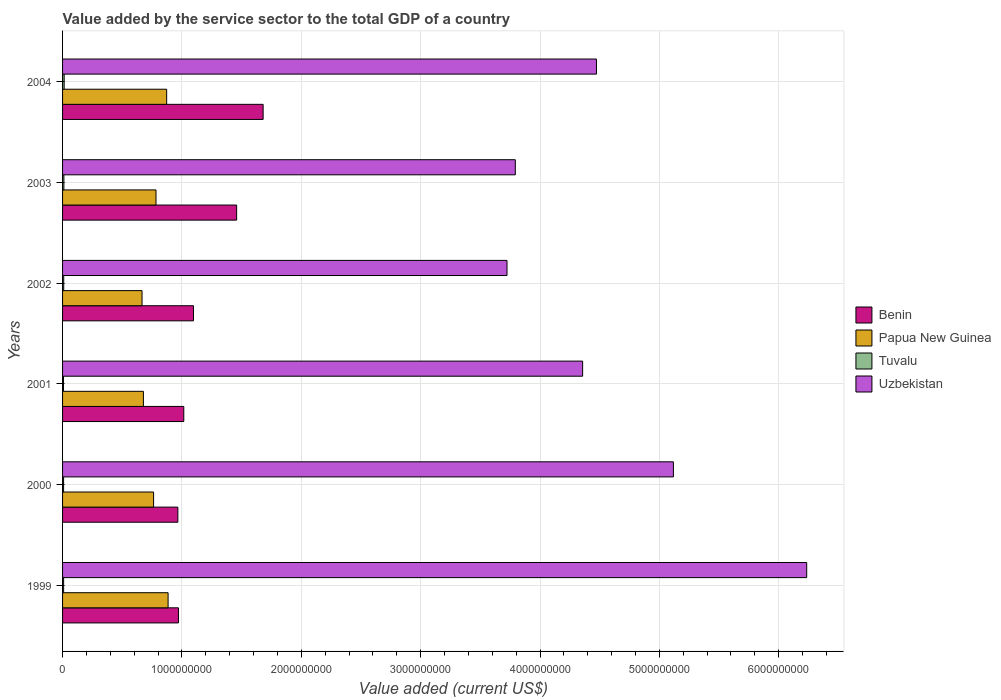How many different coloured bars are there?
Offer a terse response. 4. How many groups of bars are there?
Provide a succinct answer. 6. Are the number of bars per tick equal to the number of legend labels?
Keep it short and to the point. Yes. Are the number of bars on each tick of the Y-axis equal?
Your response must be concise. Yes. What is the value added by the service sector to the total GDP in Tuvalu in 2000?
Your answer should be very brief. 8.64e+06. Across all years, what is the maximum value added by the service sector to the total GDP in Papua New Guinea?
Offer a very short reply. 8.84e+08. Across all years, what is the minimum value added by the service sector to the total GDP in Uzbekistan?
Give a very brief answer. 3.72e+09. What is the total value added by the service sector to the total GDP in Uzbekistan in the graph?
Keep it short and to the point. 2.77e+1. What is the difference between the value added by the service sector to the total GDP in Papua New Guinea in 1999 and that in 2001?
Make the answer very short. 2.07e+08. What is the difference between the value added by the service sector to the total GDP in Tuvalu in 2004 and the value added by the service sector to the total GDP in Benin in 2000?
Make the answer very short. -9.53e+08. What is the average value added by the service sector to the total GDP in Benin per year?
Give a very brief answer. 1.20e+09. In the year 2004, what is the difference between the value added by the service sector to the total GDP in Benin and value added by the service sector to the total GDP in Tuvalu?
Ensure brevity in your answer.  1.67e+09. In how many years, is the value added by the service sector to the total GDP in Uzbekistan greater than 3800000000 US$?
Your answer should be very brief. 4. What is the ratio of the value added by the service sector to the total GDP in Tuvalu in 2000 to that in 2001?
Give a very brief answer. 1.09. What is the difference between the highest and the second highest value added by the service sector to the total GDP in Tuvalu?
Make the answer very short. 2.23e+06. What is the difference between the highest and the lowest value added by the service sector to the total GDP in Uzbekistan?
Your response must be concise. 2.51e+09. Is it the case that in every year, the sum of the value added by the service sector to the total GDP in Uzbekistan and value added by the service sector to the total GDP in Tuvalu is greater than the sum of value added by the service sector to the total GDP in Papua New Guinea and value added by the service sector to the total GDP in Benin?
Your response must be concise. Yes. What does the 2nd bar from the top in 2004 represents?
Give a very brief answer. Tuvalu. What does the 3rd bar from the bottom in 2000 represents?
Provide a succinct answer. Tuvalu. Are all the bars in the graph horizontal?
Offer a terse response. Yes. How many years are there in the graph?
Give a very brief answer. 6. What is the difference between two consecutive major ticks on the X-axis?
Your response must be concise. 1.00e+09. Are the values on the major ticks of X-axis written in scientific E-notation?
Your answer should be very brief. No. How are the legend labels stacked?
Your answer should be compact. Vertical. What is the title of the graph?
Your answer should be compact. Value added by the service sector to the total GDP of a country. What is the label or title of the X-axis?
Offer a terse response. Value added (current US$). What is the label or title of the Y-axis?
Provide a succinct answer. Years. What is the Value added (current US$) of Benin in 1999?
Your answer should be compact. 9.71e+08. What is the Value added (current US$) of Papua New Guinea in 1999?
Provide a succinct answer. 8.84e+08. What is the Value added (current US$) of Tuvalu in 1999?
Ensure brevity in your answer.  8.89e+06. What is the Value added (current US$) of Uzbekistan in 1999?
Keep it short and to the point. 6.23e+09. What is the Value added (current US$) of Benin in 2000?
Provide a succinct answer. 9.66e+08. What is the Value added (current US$) of Papua New Guinea in 2000?
Ensure brevity in your answer.  7.63e+08. What is the Value added (current US$) in Tuvalu in 2000?
Offer a very short reply. 8.64e+06. What is the Value added (current US$) in Uzbekistan in 2000?
Your response must be concise. 5.12e+09. What is the Value added (current US$) in Benin in 2001?
Give a very brief answer. 1.02e+09. What is the Value added (current US$) of Papua New Guinea in 2001?
Ensure brevity in your answer.  6.77e+08. What is the Value added (current US$) of Tuvalu in 2001?
Your answer should be very brief. 7.93e+06. What is the Value added (current US$) in Uzbekistan in 2001?
Your answer should be very brief. 4.36e+09. What is the Value added (current US$) in Benin in 2002?
Your answer should be compact. 1.10e+09. What is the Value added (current US$) of Papua New Guinea in 2002?
Your response must be concise. 6.66e+08. What is the Value added (current US$) in Tuvalu in 2002?
Your answer should be compact. 9.67e+06. What is the Value added (current US$) in Uzbekistan in 2002?
Provide a succinct answer. 3.72e+09. What is the Value added (current US$) in Benin in 2003?
Offer a very short reply. 1.46e+09. What is the Value added (current US$) in Papua New Guinea in 2003?
Give a very brief answer. 7.83e+08. What is the Value added (current US$) of Tuvalu in 2003?
Provide a short and direct response. 1.11e+07. What is the Value added (current US$) of Uzbekistan in 2003?
Provide a short and direct response. 3.79e+09. What is the Value added (current US$) in Benin in 2004?
Give a very brief answer. 1.68e+09. What is the Value added (current US$) in Papua New Guinea in 2004?
Your response must be concise. 8.72e+08. What is the Value added (current US$) in Tuvalu in 2004?
Give a very brief answer. 1.33e+07. What is the Value added (current US$) in Uzbekistan in 2004?
Offer a terse response. 4.47e+09. Across all years, what is the maximum Value added (current US$) of Benin?
Give a very brief answer. 1.68e+09. Across all years, what is the maximum Value added (current US$) of Papua New Guinea?
Ensure brevity in your answer.  8.84e+08. Across all years, what is the maximum Value added (current US$) of Tuvalu?
Offer a terse response. 1.33e+07. Across all years, what is the maximum Value added (current US$) of Uzbekistan?
Provide a succinct answer. 6.23e+09. Across all years, what is the minimum Value added (current US$) in Benin?
Ensure brevity in your answer.  9.66e+08. Across all years, what is the minimum Value added (current US$) in Papua New Guinea?
Offer a very short reply. 6.66e+08. Across all years, what is the minimum Value added (current US$) of Tuvalu?
Make the answer very short. 7.93e+06. Across all years, what is the minimum Value added (current US$) of Uzbekistan?
Your answer should be compact. 3.72e+09. What is the total Value added (current US$) in Benin in the graph?
Offer a very short reply. 7.19e+09. What is the total Value added (current US$) in Papua New Guinea in the graph?
Provide a short and direct response. 4.64e+09. What is the total Value added (current US$) of Tuvalu in the graph?
Your answer should be compact. 5.96e+07. What is the total Value added (current US$) in Uzbekistan in the graph?
Offer a very short reply. 2.77e+1. What is the difference between the Value added (current US$) in Benin in 1999 and that in 2000?
Ensure brevity in your answer.  5.03e+06. What is the difference between the Value added (current US$) of Papua New Guinea in 1999 and that in 2000?
Ensure brevity in your answer.  1.21e+08. What is the difference between the Value added (current US$) in Tuvalu in 1999 and that in 2000?
Give a very brief answer. 2.47e+05. What is the difference between the Value added (current US$) in Uzbekistan in 1999 and that in 2000?
Give a very brief answer. 1.12e+09. What is the difference between the Value added (current US$) in Benin in 1999 and that in 2001?
Provide a short and direct response. -4.46e+07. What is the difference between the Value added (current US$) in Papua New Guinea in 1999 and that in 2001?
Your answer should be compact. 2.07e+08. What is the difference between the Value added (current US$) in Tuvalu in 1999 and that in 2001?
Offer a very short reply. 9.64e+05. What is the difference between the Value added (current US$) in Uzbekistan in 1999 and that in 2001?
Your answer should be very brief. 1.88e+09. What is the difference between the Value added (current US$) of Benin in 1999 and that in 2002?
Give a very brief answer. -1.26e+08. What is the difference between the Value added (current US$) in Papua New Guinea in 1999 and that in 2002?
Keep it short and to the point. 2.18e+08. What is the difference between the Value added (current US$) in Tuvalu in 1999 and that in 2002?
Your answer should be very brief. -7.76e+05. What is the difference between the Value added (current US$) of Uzbekistan in 1999 and that in 2002?
Offer a very short reply. 2.51e+09. What is the difference between the Value added (current US$) of Benin in 1999 and that in 2003?
Provide a short and direct response. -4.87e+08. What is the difference between the Value added (current US$) of Papua New Guinea in 1999 and that in 2003?
Provide a succinct answer. 1.01e+08. What is the difference between the Value added (current US$) in Tuvalu in 1999 and that in 2003?
Give a very brief answer. -2.22e+06. What is the difference between the Value added (current US$) in Uzbekistan in 1999 and that in 2003?
Provide a short and direct response. 2.44e+09. What is the difference between the Value added (current US$) in Benin in 1999 and that in 2004?
Provide a succinct answer. -7.09e+08. What is the difference between the Value added (current US$) of Papua New Guinea in 1999 and that in 2004?
Ensure brevity in your answer.  1.20e+07. What is the difference between the Value added (current US$) in Tuvalu in 1999 and that in 2004?
Your response must be concise. -4.46e+06. What is the difference between the Value added (current US$) of Uzbekistan in 1999 and that in 2004?
Provide a succinct answer. 1.76e+09. What is the difference between the Value added (current US$) of Benin in 2000 and that in 2001?
Your answer should be compact. -4.96e+07. What is the difference between the Value added (current US$) in Papua New Guinea in 2000 and that in 2001?
Offer a terse response. 8.54e+07. What is the difference between the Value added (current US$) in Tuvalu in 2000 and that in 2001?
Offer a terse response. 7.17e+05. What is the difference between the Value added (current US$) of Uzbekistan in 2000 and that in 2001?
Ensure brevity in your answer.  7.60e+08. What is the difference between the Value added (current US$) in Benin in 2000 and that in 2002?
Keep it short and to the point. -1.31e+08. What is the difference between the Value added (current US$) in Papua New Guinea in 2000 and that in 2002?
Offer a very short reply. 9.69e+07. What is the difference between the Value added (current US$) of Tuvalu in 2000 and that in 2002?
Keep it short and to the point. -1.02e+06. What is the difference between the Value added (current US$) of Uzbekistan in 2000 and that in 2002?
Offer a terse response. 1.39e+09. What is the difference between the Value added (current US$) in Benin in 2000 and that in 2003?
Provide a succinct answer. -4.92e+08. What is the difference between the Value added (current US$) of Papua New Guinea in 2000 and that in 2003?
Give a very brief answer. -2.01e+07. What is the difference between the Value added (current US$) in Tuvalu in 2000 and that in 2003?
Offer a terse response. -2.47e+06. What is the difference between the Value added (current US$) in Uzbekistan in 2000 and that in 2003?
Ensure brevity in your answer.  1.32e+09. What is the difference between the Value added (current US$) of Benin in 2000 and that in 2004?
Your answer should be very brief. -7.14e+08. What is the difference between the Value added (current US$) of Papua New Guinea in 2000 and that in 2004?
Your response must be concise. -1.09e+08. What is the difference between the Value added (current US$) of Tuvalu in 2000 and that in 2004?
Make the answer very short. -4.70e+06. What is the difference between the Value added (current US$) of Uzbekistan in 2000 and that in 2004?
Offer a very short reply. 6.45e+08. What is the difference between the Value added (current US$) in Benin in 2001 and that in 2002?
Make the answer very short. -8.14e+07. What is the difference between the Value added (current US$) of Papua New Guinea in 2001 and that in 2002?
Keep it short and to the point. 1.15e+07. What is the difference between the Value added (current US$) of Tuvalu in 2001 and that in 2002?
Offer a very short reply. -1.74e+06. What is the difference between the Value added (current US$) of Uzbekistan in 2001 and that in 2002?
Your answer should be compact. 6.34e+08. What is the difference between the Value added (current US$) in Benin in 2001 and that in 2003?
Provide a short and direct response. -4.43e+08. What is the difference between the Value added (current US$) of Papua New Guinea in 2001 and that in 2003?
Your answer should be compact. -1.06e+08. What is the difference between the Value added (current US$) of Tuvalu in 2001 and that in 2003?
Provide a short and direct response. -3.19e+06. What is the difference between the Value added (current US$) in Uzbekistan in 2001 and that in 2003?
Provide a short and direct response. 5.64e+08. What is the difference between the Value added (current US$) of Benin in 2001 and that in 2004?
Make the answer very short. -6.65e+08. What is the difference between the Value added (current US$) in Papua New Guinea in 2001 and that in 2004?
Ensure brevity in your answer.  -1.95e+08. What is the difference between the Value added (current US$) of Tuvalu in 2001 and that in 2004?
Offer a very short reply. -5.42e+06. What is the difference between the Value added (current US$) in Uzbekistan in 2001 and that in 2004?
Provide a short and direct response. -1.16e+08. What is the difference between the Value added (current US$) in Benin in 2002 and that in 2003?
Provide a short and direct response. -3.61e+08. What is the difference between the Value added (current US$) in Papua New Guinea in 2002 and that in 2003?
Offer a terse response. -1.17e+08. What is the difference between the Value added (current US$) in Tuvalu in 2002 and that in 2003?
Your answer should be very brief. -1.45e+06. What is the difference between the Value added (current US$) of Uzbekistan in 2002 and that in 2003?
Provide a short and direct response. -6.96e+07. What is the difference between the Value added (current US$) of Benin in 2002 and that in 2004?
Your response must be concise. -5.83e+08. What is the difference between the Value added (current US$) of Papua New Guinea in 2002 and that in 2004?
Your answer should be compact. -2.06e+08. What is the difference between the Value added (current US$) of Tuvalu in 2002 and that in 2004?
Offer a very short reply. -3.68e+06. What is the difference between the Value added (current US$) in Uzbekistan in 2002 and that in 2004?
Offer a terse response. -7.49e+08. What is the difference between the Value added (current US$) in Benin in 2003 and that in 2004?
Your answer should be very brief. -2.22e+08. What is the difference between the Value added (current US$) in Papua New Guinea in 2003 and that in 2004?
Ensure brevity in your answer.  -8.93e+07. What is the difference between the Value added (current US$) in Tuvalu in 2003 and that in 2004?
Provide a short and direct response. -2.23e+06. What is the difference between the Value added (current US$) of Uzbekistan in 2003 and that in 2004?
Provide a short and direct response. -6.80e+08. What is the difference between the Value added (current US$) in Benin in 1999 and the Value added (current US$) in Papua New Guinea in 2000?
Offer a terse response. 2.08e+08. What is the difference between the Value added (current US$) in Benin in 1999 and the Value added (current US$) in Tuvalu in 2000?
Provide a succinct answer. 9.62e+08. What is the difference between the Value added (current US$) of Benin in 1999 and the Value added (current US$) of Uzbekistan in 2000?
Offer a very short reply. -4.15e+09. What is the difference between the Value added (current US$) of Papua New Guinea in 1999 and the Value added (current US$) of Tuvalu in 2000?
Your answer should be very brief. 8.75e+08. What is the difference between the Value added (current US$) of Papua New Guinea in 1999 and the Value added (current US$) of Uzbekistan in 2000?
Your response must be concise. -4.23e+09. What is the difference between the Value added (current US$) in Tuvalu in 1999 and the Value added (current US$) in Uzbekistan in 2000?
Your answer should be compact. -5.11e+09. What is the difference between the Value added (current US$) of Benin in 1999 and the Value added (current US$) of Papua New Guinea in 2001?
Ensure brevity in your answer.  2.94e+08. What is the difference between the Value added (current US$) in Benin in 1999 and the Value added (current US$) in Tuvalu in 2001?
Provide a succinct answer. 9.63e+08. What is the difference between the Value added (current US$) in Benin in 1999 and the Value added (current US$) in Uzbekistan in 2001?
Provide a short and direct response. -3.39e+09. What is the difference between the Value added (current US$) in Papua New Guinea in 1999 and the Value added (current US$) in Tuvalu in 2001?
Your answer should be very brief. 8.76e+08. What is the difference between the Value added (current US$) of Papua New Guinea in 1999 and the Value added (current US$) of Uzbekistan in 2001?
Your answer should be very brief. -3.47e+09. What is the difference between the Value added (current US$) of Tuvalu in 1999 and the Value added (current US$) of Uzbekistan in 2001?
Offer a very short reply. -4.35e+09. What is the difference between the Value added (current US$) of Benin in 1999 and the Value added (current US$) of Papua New Guinea in 2002?
Make the answer very short. 3.05e+08. What is the difference between the Value added (current US$) of Benin in 1999 and the Value added (current US$) of Tuvalu in 2002?
Provide a succinct answer. 9.61e+08. What is the difference between the Value added (current US$) in Benin in 1999 and the Value added (current US$) in Uzbekistan in 2002?
Provide a succinct answer. -2.75e+09. What is the difference between the Value added (current US$) in Papua New Guinea in 1999 and the Value added (current US$) in Tuvalu in 2002?
Your answer should be compact. 8.74e+08. What is the difference between the Value added (current US$) in Papua New Guinea in 1999 and the Value added (current US$) in Uzbekistan in 2002?
Offer a terse response. -2.84e+09. What is the difference between the Value added (current US$) in Tuvalu in 1999 and the Value added (current US$) in Uzbekistan in 2002?
Keep it short and to the point. -3.71e+09. What is the difference between the Value added (current US$) in Benin in 1999 and the Value added (current US$) in Papua New Guinea in 2003?
Give a very brief answer. 1.88e+08. What is the difference between the Value added (current US$) of Benin in 1999 and the Value added (current US$) of Tuvalu in 2003?
Offer a very short reply. 9.60e+08. What is the difference between the Value added (current US$) in Benin in 1999 and the Value added (current US$) in Uzbekistan in 2003?
Your answer should be compact. -2.82e+09. What is the difference between the Value added (current US$) of Papua New Guinea in 1999 and the Value added (current US$) of Tuvalu in 2003?
Your response must be concise. 8.73e+08. What is the difference between the Value added (current US$) in Papua New Guinea in 1999 and the Value added (current US$) in Uzbekistan in 2003?
Your answer should be compact. -2.91e+09. What is the difference between the Value added (current US$) in Tuvalu in 1999 and the Value added (current US$) in Uzbekistan in 2003?
Your answer should be very brief. -3.78e+09. What is the difference between the Value added (current US$) in Benin in 1999 and the Value added (current US$) in Papua New Guinea in 2004?
Give a very brief answer. 9.89e+07. What is the difference between the Value added (current US$) of Benin in 1999 and the Value added (current US$) of Tuvalu in 2004?
Offer a very short reply. 9.58e+08. What is the difference between the Value added (current US$) in Benin in 1999 and the Value added (current US$) in Uzbekistan in 2004?
Offer a terse response. -3.50e+09. What is the difference between the Value added (current US$) of Papua New Guinea in 1999 and the Value added (current US$) of Tuvalu in 2004?
Your answer should be very brief. 8.71e+08. What is the difference between the Value added (current US$) in Papua New Guinea in 1999 and the Value added (current US$) in Uzbekistan in 2004?
Give a very brief answer. -3.59e+09. What is the difference between the Value added (current US$) of Tuvalu in 1999 and the Value added (current US$) of Uzbekistan in 2004?
Your answer should be compact. -4.46e+09. What is the difference between the Value added (current US$) of Benin in 2000 and the Value added (current US$) of Papua New Guinea in 2001?
Keep it short and to the point. 2.89e+08. What is the difference between the Value added (current US$) of Benin in 2000 and the Value added (current US$) of Tuvalu in 2001?
Ensure brevity in your answer.  9.58e+08. What is the difference between the Value added (current US$) of Benin in 2000 and the Value added (current US$) of Uzbekistan in 2001?
Provide a short and direct response. -3.39e+09. What is the difference between the Value added (current US$) in Papua New Guinea in 2000 and the Value added (current US$) in Tuvalu in 2001?
Provide a succinct answer. 7.55e+08. What is the difference between the Value added (current US$) of Papua New Guinea in 2000 and the Value added (current US$) of Uzbekistan in 2001?
Provide a succinct answer. -3.59e+09. What is the difference between the Value added (current US$) in Tuvalu in 2000 and the Value added (current US$) in Uzbekistan in 2001?
Provide a short and direct response. -4.35e+09. What is the difference between the Value added (current US$) of Benin in 2000 and the Value added (current US$) of Papua New Guinea in 2002?
Your answer should be compact. 3.00e+08. What is the difference between the Value added (current US$) in Benin in 2000 and the Value added (current US$) in Tuvalu in 2002?
Provide a succinct answer. 9.56e+08. What is the difference between the Value added (current US$) in Benin in 2000 and the Value added (current US$) in Uzbekistan in 2002?
Keep it short and to the point. -2.76e+09. What is the difference between the Value added (current US$) of Papua New Guinea in 2000 and the Value added (current US$) of Tuvalu in 2002?
Offer a terse response. 7.53e+08. What is the difference between the Value added (current US$) of Papua New Guinea in 2000 and the Value added (current US$) of Uzbekistan in 2002?
Offer a terse response. -2.96e+09. What is the difference between the Value added (current US$) of Tuvalu in 2000 and the Value added (current US$) of Uzbekistan in 2002?
Your answer should be compact. -3.71e+09. What is the difference between the Value added (current US$) of Benin in 2000 and the Value added (current US$) of Papua New Guinea in 2003?
Make the answer very short. 1.83e+08. What is the difference between the Value added (current US$) in Benin in 2000 and the Value added (current US$) in Tuvalu in 2003?
Your response must be concise. 9.55e+08. What is the difference between the Value added (current US$) in Benin in 2000 and the Value added (current US$) in Uzbekistan in 2003?
Make the answer very short. -2.83e+09. What is the difference between the Value added (current US$) of Papua New Guinea in 2000 and the Value added (current US$) of Tuvalu in 2003?
Offer a very short reply. 7.52e+08. What is the difference between the Value added (current US$) in Papua New Guinea in 2000 and the Value added (current US$) in Uzbekistan in 2003?
Offer a terse response. -3.03e+09. What is the difference between the Value added (current US$) of Tuvalu in 2000 and the Value added (current US$) of Uzbekistan in 2003?
Offer a very short reply. -3.78e+09. What is the difference between the Value added (current US$) in Benin in 2000 and the Value added (current US$) in Papua New Guinea in 2004?
Keep it short and to the point. 9.39e+07. What is the difference between the Value added (current US$) in Benin in 2000 and the Value added (current US$) in Tuvalu in 2004?
Keep it short and to the point. 9.53e+08. What is the difference between the Value added (current US$) of Benin in 2000 and the Value added (current US$) of Uzbekistan in 2004?
Your answer should be compact. -3.51e+09. What is the difference between the Value added (current US$) in Papua New Guinea in 2000 and the Value added (current US$) in Tuvalu in 2004?
Give a very brief answer. 7.49e+08. What is the difference between the Value added (current US$) of Papua New Guinea in 2000 and the Value added (current US$) of Uzbekistan in 2004?
Provide a short and direct response. -3.71e+09. What is the difference between the Value added (current US$) in Tuvalu in 2000 and the Value added (current US$) in Uzbekistan in 2004?
Your response must be concise. -4.46e+09. What is the difference between the Value added (current US$) in Benin in 2001 and the Value added (current US$) in Papua New Guinea in 2002?
Your response must be concise. 3.50e+08. What is the difference between the Value added (current US$) in Benin in 2001 and the Value added (current US$) in Tuvalu in 2002?
Provide a short and direct response. 1.01e+09. What is the difference between the Value added (current US$) in Benin in 2001 and the Value added (current US$) in Uzbekistan in 2002?
Provide a succinct answer. -2.71e+09. What is the difference between the Value added (current US$) of Papua New Guinea in 2001 and the Value added (current US$) of Tuvalu in 2002?
Your answer should be compact. 6.68e+08. What is the difference between the Value added (current US$) in Papua New Guinea in 2001 and the Value added (current US$) in Uzbekistan in 2002?
Provide a short and direct response. -3.05e+09. What is the difference between the Value added (current US$) of Tuvalu in 2001 and the Value added (current US$) of Uzbekistan in 2002?
Your answer should be compact. -3.72e+09. What is the difference between the Value added (current US$) of Benin in 2001 and the Value added (current US$) of Papua New Guinea in 2003?
Provide a succinct answer. 2.33e+08. What is the difference between the Value added (current US$) of Benin in 2001 and the Value added (current US$) of Tuvalu in 2003?
Provide a short and direct response. 1.00e+09. What is the difference between the Value added (current US$) in Benin in 2001 and the Value added (current US$) in Uzbekistan in 2003?
Offer a very short reply. -2.78e+09. What is the difference between the Value added (current US$) in Papua New Guinea in 2001 and the Value added (current US$) in Tuvalu in 2003?
Offer a very short reply. 6.66e+08. What is the difference between the Value added (current US$) of Papua New Guinea in 2001 and the Value added (current US$) of Uzbekistan in 2003?
Keep it short and to the point. -3.12e+09. What is the difference between the Value added (current US$) of Tuvalu in 2001 and the Value added (current US$) of Uzbekistan in 2003?
Your answer should be compact. -3.79e+09. What is the difference between the Value added (current US$) in Benin in 2001 and the Value added (current US$) in Papua New Guinea in 2004?
Your answer should be very brief. 1.43e+08. What is the difference between the Value added (current US$) in Benin in 2001 and the Value added (current US$) in Tuvalu in 2004?
Make the answer very short. 1.00e+09. What is the difference between the Value added (current US$) in Benin in 2001 and the Value added (current US$) in Uzbekistan in 2004?
Make the answer very short. -3.46e+09. What is the difference between the Value added (current US$) in Papua New Guinea in 2001 and the Value added (current US$) in Tuvalu in 2004?
Your answer should be compact. 6.64e+08. What is the difference between the Value added (current US$) of Papua New Guinea in 2001 and the Value added (current US$) of Uzbekistan in 2004?
Offer a terse response. -3.80e+09. What is the difference between the Value added (current US$) of Tuvalu in 2001 and the Value added (current US$) of Uzbekistan in 2004?
Provide a short and direct response. -4.47e+09. What is the difference between the Value added (current US$) in Benin in 2002 and the Value added (current US$) in Papua New Guinea in 2003?
Make the answer very short. 3.14e+08. What is the difference between the Value added (current US$) in Benin in 2002 and the Value added (current US$) in Tuvalu in 2003?
Provide a succinct answer. 1.09e+09. What is the difference between the Value added (current US$) of Benin in 2002 and the Value added (current US$) of Uzbekistan in 2003?
Offer a terse response. -2.70e+09. What is the difference between the Value added (current US$) of Papua New Guinea in 2002 and the Value added (current US$) of Tuvalu in 2003?
Offer a very short reply. 6.55e+08. What is the difference between the Value added (current US$) in Papua New Guinea in 2002 and the Value added (current US$) in Uzbekistan in 2003?
Your answer should be very brief. -3.13e+09. What is the difference between the Value added (current US$) in Tuvalu in 2002 and the Value added (current US$) in Uzbekistan in 2003?
Keep it short and to the point. -3.78e+09. What is the difference between the Value added (current US$) in Benin in 2002 and the Value added (current US$) in Papua New Guinea in 2004?
Provide a short and direct response. 2.25e+08. What is the difference between the Value added (current US$) of Benin in 2002 and the Value added (current US$) of Tuvalu in 2004?
Provide a succinct answer. 1.08e+09. What is the difference between the Value added (current US$) of Benin in 2002 and the Value added (current US$) of Uzbekistan in 2004?
Offer a very short reply. -3.38e+09. What is the difference between the Value added (current US$) in Papua New Guinea in 2002 and the Value added (current US$) in Tuvalu in 2004?
Ensure brevity in your answer.  6.52e+08. What is the difference between the Value added (current US$) in Papua New Guinea in 2002 and the Value added (current US$) in Uzbekistan in 2004?
Make the answer very short. -3.81e+09. What is the difference between the Value added (current US$) of Tuvalu in 2002 and the Value added (current US$) of Uzbekistan in 2004?
Provide a succinct answer. -4.46e+09. What is the difference between the Value added (current US$) in Benin in 2003 and the Value added (current US$) in Papua New Guinea in 2004?
Your answer should be very brief. 5.86e+08. What is the difference between the Value added (current US$) of Benin in 2003 and the Value added (current US$) of Tuvalu in 2004?
Your answer should be very brief. 1.45e+09. What is the difference between the Value added (current US$) of Benin in 2003 and the Value added (current US$) of Uzbekistan in 2004?
Make the answer very short. -3.01e+09. What is the difference between the Value added (current US$) in Papua New Guinea in 2003 and the Value added (current US$) in Tuvalu in 2004?
Give a very brief answer. 7.69e+08. What is the difference between the Value added (current US$) of Papua New Guinea in 2003 and the Value added (current US$) of Uzbekistan in 2004?
Ensure brevity in your answer.  -3.69e+09. What is the difference between the Value added (current US$) of Tuvalu in 2003 and the Value added (current US$) of Uzbekistan in 2004?
Offer a terse response. -4.46e+09. What is the average Value added (current US$) in Benin per year?
Your answer should be very brief. 1.20e+09. What is the average Value added (current US$) of Papua New Guinea per year?
Your answer should be very brief. 7.74e+08. What is the average Value added (current US$) in Tuvalu per year?
Your response must be concise. 9.93e+06. What is the average Value added (current US$) in Uzbekistan per year?
Your answer should be very brief. 4.62e+09. In the year 1999, what is the difference between the Value added (current US$) in Benin and Value added (current US$) in Papua New Guinea?
Make the answer very short. 8.69e+07. In the year 1999, what is the difference between the Value added (current US$) of Benin and Value added (current US$) of Tuvalu?
Offer a very short reply. 9.62e+08. In the year 1999, what is the difference between the Value added (current US$) of Benin and Value added (current US$) of Uzbekistan?
Keep it short and to the point. -5.26e+09. In the year 1999, what is the difference between the Value added (current US$) in Papua New Guinea and Value added (current US$) in Tuvalu?
Keep it short and to the point. 8.75e+08. In the year 1999, what is the difference between the Value added (current US$) in Papua New Guinea and Value added (current US$) in Uzbekistan?
Provide a succinct answer. -5.35e+09. In the year 1999, what is the difference between the Value added (current US$) in Tuvalu and Value added (current US$) in Uzbekistan?
Make the answer very short. -6.23e+09. In the year 2000, what is the difference between the Value added (current US$) in Benin and Value added (current US$) in Papua New Guinea?
Keep it short and to the point. 2.03e+08. In the year 2000, what is the difference between the Value added (current US$) of Benin and Value added (current US$) of Tuvalu?
Offer a very short reply. 9.57e+08. In the year 2000, what is the difference between the Value added (current US$) in Benin and Value added (current US$) in Uzbekistan?
Provide a succinct answer. -4.15e+09. In the year 2000, what is the difference between the Value added (current US$) of Papua New Guinea and Value added (current US$) of Tuvalu?
Make the answer very short. 7.54e+08. In the year 2000, what is the difference between the Value added (current US$) of Papua New Guinea and Value added (current US$) of Uzbekistan?
Keep it short and to the point. -4.35e+09. In the year 2000, what is the difference between the Value added (current US$) in Tuvalu and Value added (current US$) in Uzbekistan?
Provide a short and direct response. -5.11e+09. In the year 2001, what is the difference between the Value added (current US$) in Benin and Value added (current US$) in Papua New Guinea?
Make the answer very short. 3.38e+08. In the year 2001, what is the difference between the Value added (current US$) in Benin and Value added (current US$) in Tuvalu?
Your answer should be compact. 1.01e+09. In the year 2001, what is the difference between the Value added (current US$) in Benin and Value added (current US$) in Uzbekistan?
Offer a very short reply. -3.34e+09. In the year 2001, what is the difference between the Value added (current US$) in Papua New Guinea and Value added (current US$) in Tuvalu?
Make the answer very short. 6.69e+08. In the year 2001, what is the difference between the Value added (current US$) in Papua New Guinea and Value added (current US$) in Uzbekistan?
Provide a short and direct response. -3.68e+09. In the year 2001, what is the difference between the Value added (current US$) of Tuvalu and Value added (current US$) of Uzbekistan?
Provide a succinct answer. -4.35e+09. In the year 2002, what is the difference between the Value added (current US$) of Benin and Value added (current US$) of Papua New Guinea?
Offer a terse response. 4.31e+08. In the year 2002, what is the difference between the Value added (current US$) of Benin and Value added (current US$) of Tuvalu?
Keep it short and to the point. 1.09e+09. In the year 2002, what is the difference between the Value added (current US$) of Benin and Value added (current US$) of Uzbekistan?
Offer a terse response. -2.63e+09. In the year 2002, what is the difference between the Value added (current US$) of Papua New Guinea and Value added (current US$) of Tuvalu?
Ensure brevity in your answer.  6.56e+08. In the year 2002, what is the difference between the Value added (current US$) in Papua New Guinea and Value added (current US$) in Uzbekistan?
Keep it short and to the point. -3.06e+09. In the year 2002, what is the difference between the Value added (current US$) of Tuvalu and Value added (current US$) of Uzbekistan?
Provide a succinct answer. -3.71e+09. In the year 2003, what is the difference between the Value added (current US$) in Benin and Value added (current US$) in Papua New Guinea?
Your answer should be compact. 6.76e+08. In the year 2003, what is the difference between the Value added (current US$) of Benin and Value added (current US$) of Tuvalu?
Ensure brevity in your answer.  1.45e+09. In the year 2003, what is the difference between the Value added (current US$) in Benin and Value added (current US$) in Uzbekistan?
Provide a short and direct response. -2.33e+09. In the year 2003, what is the difference between the Value added (current US$) of Papua New Guinea and Value added (current US$) of Tuvalu?
Your answer should be compact. 7.72e+08. In the year 2003, what is the difference between the Value added (current US$) of Papua New Guinea and Value added (current US$) of Uzbekistan?
Provide a short and direct response. -3.01e+09. In the year 2003, what is the difference between the Value added (current US$) of Tuvalu and Value added (current US$) of Uzbekistan?
Make the answer very short. -3.78e+09. In the year 2004, what is the difference between the Value added (current US$) of Benin and Value added (current US$) of Papua New Guinea?
Your answer should be compact. 8.08e+08. In the year 2004, what is the difference between the Value added (current US$) in Benin and Value added (current US$) in Tuvalu?
Your answer should be compact. 1.67e+09. In the year 2004, what is the difference between the Value added (current US$) in Benin and Value added (current US$) in Uzbekistan?
Offer a very short reply. -2.79e+09. In the year 2004, what is the difference between the Value added (current US$) of Papua New Guinea and Value added (current US$) of Tuvalu?
Your response must be concise. 8.59e+08. In the year 2004, what is the difference between the Value added (current US$) of Papua New Guinea and Value added (current US$) of Uzbekistan?
Provide a short and direct response. -3.60e+09. In the year 2004, what is the difference between the Value added (current US$) of Tuvalu and Value added (current US$) of Uzbekistan?
Offer a very short reply. -4.46e+09. What is the ratio of the Value added (current US$) of Benin in 1999 to that in 2000?
Offer a terse response. 1.01. What is the ratio of the Value added (current US$) in Papua New Guinea in 1999 to that in 2000?
Ensure brevity in your answer.  1.16. What is the ratio of the Value added (current US$) of Tuvalu in 1999 to that in 2000?
Make the answer very short. 1.03. What is the ratio of the Value added (current US$) of Uzbekistan in 1999 to that in 2000?
Your answer should be very brief. 1.22. What is the ratio of the Value added (current US$) of Benin in 1999 to that in 2001?
Provide a succinct answer. 0.96. What is the ratio of the Value added (current US$) in Papua New Guinea in 1999 to that in 2001?
Keep it short and to the point. 1.31. What is the ratio of the Value added (current US$) of Tuvalu in 1999 to that in 2001?
Provide a short and direct response. 1.12. What is the ratio of the Value added (current US$) of Uzbekistan in 1999 to that in 2001?
Ensure brevity in your answer.  1.43. What is the ratio of the Value added (current US$) in Benin in 1999 to that in 2002?
Keep it short and to the point. 0.89. What is the ratio of the Value added (current US$) in Papua New Guinea in 1999 to that in 2002?
Make the answer very short. 1.33. What is the ratio of the Value added (current US$) of Tuvalu in 1999 to that in 2002?
Your answer should be compact. 0.92. What is the ratio of the Value added (current US$) in Uzbekistan in 1999 to that in 2002?
Make the answer very short. 1.67. What is the ratio of the Value added (current US$) in Benin in 1999 to that in 2003?
Your answer should be very brief. 0.67. What is the ratio of the Value added (current US$) of Papua New Guinea in 1999 to that in 2003?
Your answer should be compact. 1.13. What is the ratio of the Value added (current US$) in Tuvalu in 1999 to that in 2003?
Ensure brevity in your answer.  0.8. What is the ratio of the Value added (current US$) of Uzbekistan in 1999 to that in 2003?
Your answer should be compact. 1.64. What is the ratio of the Value added (current US$) of Benin in 1999 to that in 2004?
Provide a succinct answer. 0.58. What is the ratio of the Value added (current US$) of Papua New Guinea in 1999 to that in 2004?
Keep it short and to the point. 1.01. What is the ratio of the Value added (current US$) in Tuvalu in 1999 to that in 2004?
Provide a succinct answer. 0.67. What is the ratio of the Value added (current US$) in Uzbekistan in 1999 to that in 2004?
Offer a very short reply. 1.39. What is the ratio of the Value added (current US$) of Benin in 2000 to that in 2001?
Your response must be concise. 0.95. What is the ratio of the Value added (current US$) in Papua New Guinea in 2000 to that in 2001?
Your answer should be very brief. 1.13. What is the ratio of the Value added (current US$) of Tuvalu in 2000 to that in 2001?
Offer a terse response. 1.09. What is the ratio of the Value added (current US$) of Uzbekistan in 2000 to that in 2001?
Make the answer very short. 1.17. What is the ratio of the Value added (current US$) in Benin in 2000 to that in 2002?
Offer a very short reply. 0.88. What is the ratio of the Value added (current US$) of Papua New Guinea in 2000 to that in 2002?
Your answer should be compact. 1.15. What is the ratio of the Value added (current US$) of Tuvalu in 2000 to that in 2002?
Offer a very short reply. 0.89. What is the ratio of the Value added (current US$) of Uzbekistan in 2000 to that in 2002?
Your answer should be very brief. 1.37. What is the ratio of the Value added (current US$) in Benin in 2000 to that in 2003?
Your answer should be very brief. 0.66. What is the ratio of the Value added (current US$) of Papua New Guinea in 2000 to that in 2003?
Provide a short and direct response. 0.97. What is the ratio of the Value added (current US$) in Tuvalu in 2000 to that in 2003?
Offer a terse response. 0.78. What is the ratio of the Value added (current US$) in Uzbekistan in 2000 to that in 2003?
Keep it short and to the point. 1.35. What is the ratio of the Value added (current US$) of Benin in 2000 to that in 2004?
Your answer should be compact. 0.57. What is the ratio of the Value added (current US$) of Papua New Guinea in 2000 to that in 2004?
Your answer should be very brief. 0.87. What is the ratio of the Value added (current US$) in Tuvalu in 2000 to that in 2004?
Offer a very short reply. 0.65. What is the ratio of the Value added (current US$) of Uzbekistan in 2000 to that in 2004?
Offer a very short reply. 1.14. What is the ratio of the Value added (current US$) in Benin in 2001 to that in 2002?
Your answer should be compact. 0.93. What is the ratio of the Value added (current US$) in Papua New Guinea in 2001 to that in 2002?
Keep it short and to the point. 1.02. What is the ratio of the Value added (current US$) in Tuvalu in 2001 to that in 2002?
Provide a succinct answer. 0.82. What is the ratio of the Value added (current US$) in Uzbekistan in 2001 to that in 2002?
Provide a short and direct response. 1.17. What is the ratio of the Value added (current US$) in Benin in 2001 to that in 2003?
Give a very brief answer. 0.7. What is the ratio of the Value added (current US$) of Papua New Guinea in 2001 to that in 2003?
Provide a succinct answer. 0.87. What is the ratio of the Value added (current US$) in Tuvalu in 2001 to that in 2003?
Your answer should be very brief. 0.71. What is the ratio of the Value added (current US$) in Uzbekistan in 2001 to that in 2003?
Offer a terse response. 1.15. What is the ratio of the Value added (current US$) of Benin in 2001 to that in 2004?
Provide a short and direct response. 0.6. What is the ratio of the Value added (current US$) of Papua New Guinea in 2001 to that in 2004?
Your answer should be very brief. 0.78. What is the ratio of the Value added (current US$) in Tuvalu in 2001 to that in 2004?
Make the answer very short. 0.59. What is the ratio of the Value added (current US$) in Uzbekistan in 2001 to that in 2004?
Give a very brief answer. 0.97. What is the ratio of the Value added (current US$) of Benin in 2002 to that in 2003?
Make the answer very short. 0.75. What is the ratio of the Value added (current US$) of Papua New Guinea in 2002 to that in 2003?
Your response must be concise. 0.85. What is the ratio of the Value added (current US$) of Tuvalu in 2002 to that in 2003?
Make the answer very short. 0.87. What is the ratio of the Value added (current US$) in Uzbekistan in 2002 to that in 2003?
Give a very brief answer. 0.98. What is the ratio of the Value added (current US$) of Benin in 2002 to that in 2004?
Your answer should be very brief. 0.65. What is the ratio of the Value added (current US$) of Papua New Guinea in 2002 to that in 2004?
Offer a very short reply. 0.76. What is the ratio of the Value added (current US$) in Tuvalu in 2002 to that in 2004?
Keep it short and to the point. 0.72. What is the ratio of the Value added (current US$) of Uzbekistan in 2002 to that in 2004?
Your answer should be very brief. 0.83. What is the ratio of the Value added (current US$) in Benin in 2003 to that in 2004?
Provide a short and direct response. 0.87. What is the ratio of the Value added (current US$) in Papua New Guinea in 2003 to that in 2004?
Provide a succinct answer. 0.9. What is the ratio of the Value added (current US$) of Tuvalu in 2003 to that in 2004?
Your response must be concise. 0.83. What is the ratio of the Value added (current US$) of Uzbekistan in 2003 to that in 2004?
Your answer should be very brief. 0.85. What is the difference between the highest and the second highest Value added (current US$) in Benin?
Offer a very short reply. 2.22e+08. What is the difference between the highest and the second highest Value added (current US$) of Papua New Guinea?
Provide a short and direct response. 1.20e+07. What is the difference between the highest and the second highest Value added (current US$) in Tuvalu?
Keep it short and to the point. 2.23e+06. What is the difference between the highest and the second highest Value added (current US$) of Uzbekistan?
Provide a short and direct response. 1.12e+09. What is the difference between the highest and the lowest Value added (current US$) in Benin?
Keep it short and to the point. 7.14e+08. What is the difference between the highest and the lowest Value added (current US$) of Papua New Guinea?
Your answer should be compact. 2.18e+08. What is the difference between the highest and the lowest Value added (current US$) in Tuvalu?
Keep it short and to the point. 5.42e+06. What is the difference between the highest and the lowest Value added (current US$) of Uzbekistan?
Offer a terse response. 2.51e+09. 